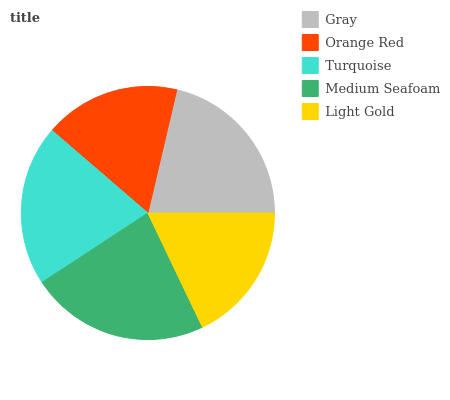Is Orange Red the minimum?
Answer yes or no. Yes. Is Medium Seafoam the maximum?
Answer yes or no. Yes. Is Turquoise the minimum?
Answer yes or no. No. Is Turquoise the maximum?
Answer yes or no. No. Is Turquoise greater than Orange Red?
Answer yes or no. Yes. Is Orange Red less than Turquoise?
Answer yes or no. Yes. Is Orange Red greater than Turquoise?
Answer yes or no. No. Is Turquoise less than Orange Red?
Answer yes or no. No. Is Turquoise the high median?
Answer yes or no. Yes. Is Turquoise the low median?
Answer yes or no. Yes. Is Medium Seafoam the high median?
Answer yes or no. No. Is Light Gold the low median?
Answer yes or no. No. 